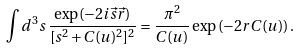<formula> <loc_0><loc_0><loc_500><loc_500>\int d ^ { 3 } s \, \frac { \exp ( - 2 i \vec { s } \vec { r } ) } { [ s ^ { 2 } + C ( u ) ^ { 2 } ] ^ { 2 } } = \frac { \pi ^ { 2 } } { C ( u ) } \exp \left ( - 2 r C ( u ) \right ) .</formula> 